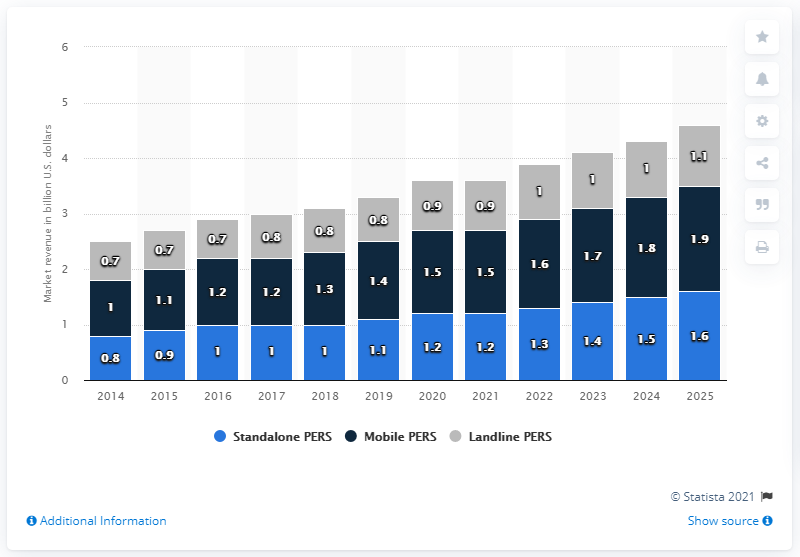Mention a couple of crucial points in this snapshot. According to a market analysis conducted in 2019, mobile PERs accounted for a significant share of the medical alert system/personal emergency response system market in the United States. Specifically, mobile PERs represented 1.9% of the overall market. 